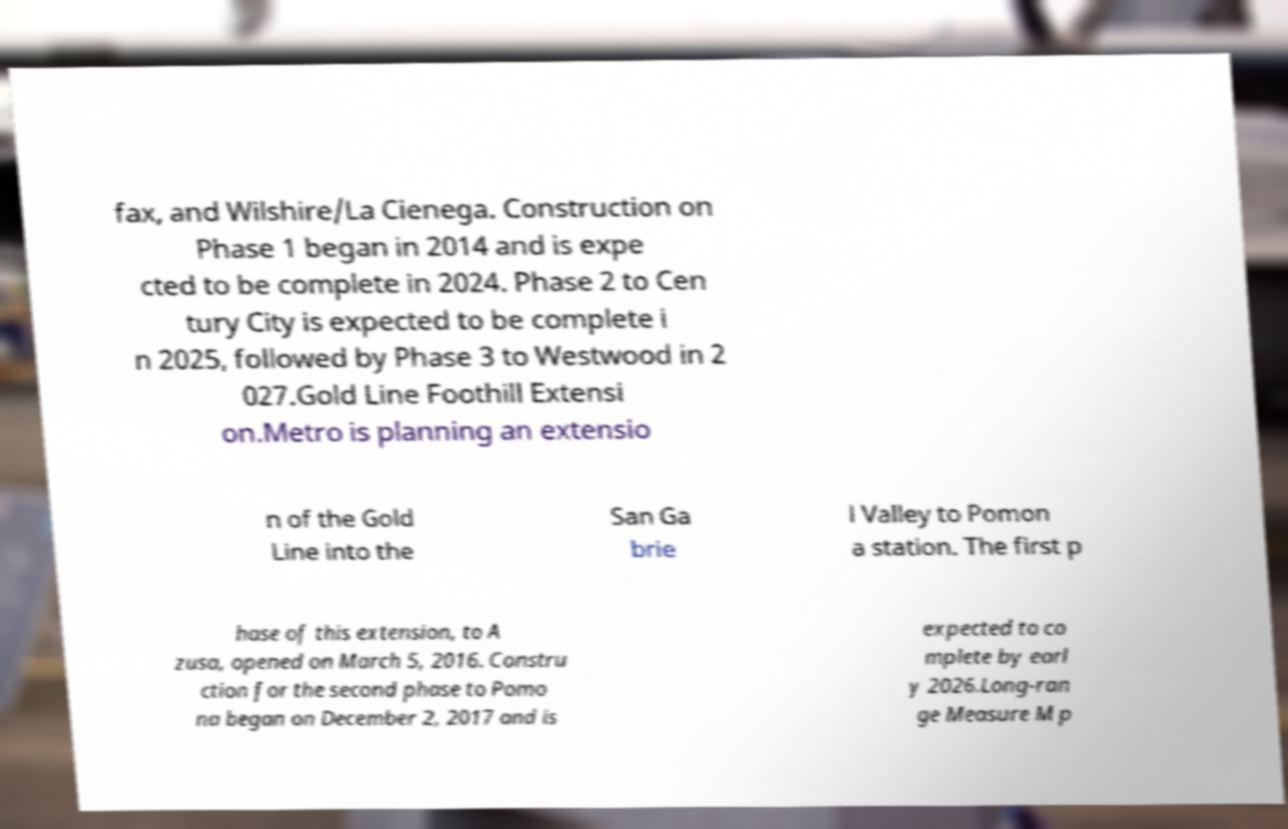Could you assist in decoding the text presented in this image and type it out clearly? fax, and Wilshire/La Cienega. Construction on Phase 1 began in 2014 and is expe cted to be complete in 2024. Phase 2 to Cen tury City is expected to be complete i n 2025, followed by Phase 3 to Westwood in 2 027.Gold Line Foothill Extensi on.Metro is planning an extensio n of the Gold Line into the San Ga brie l Valley to Pomon a station. The first p hase of this extension, to A zusa, opened on March 5, 2016. Constru ction for the second phase to Pomo na began on December 2, 2017 and is expected to co mplete by earl y 2026.Long-ran ge Measure M p 